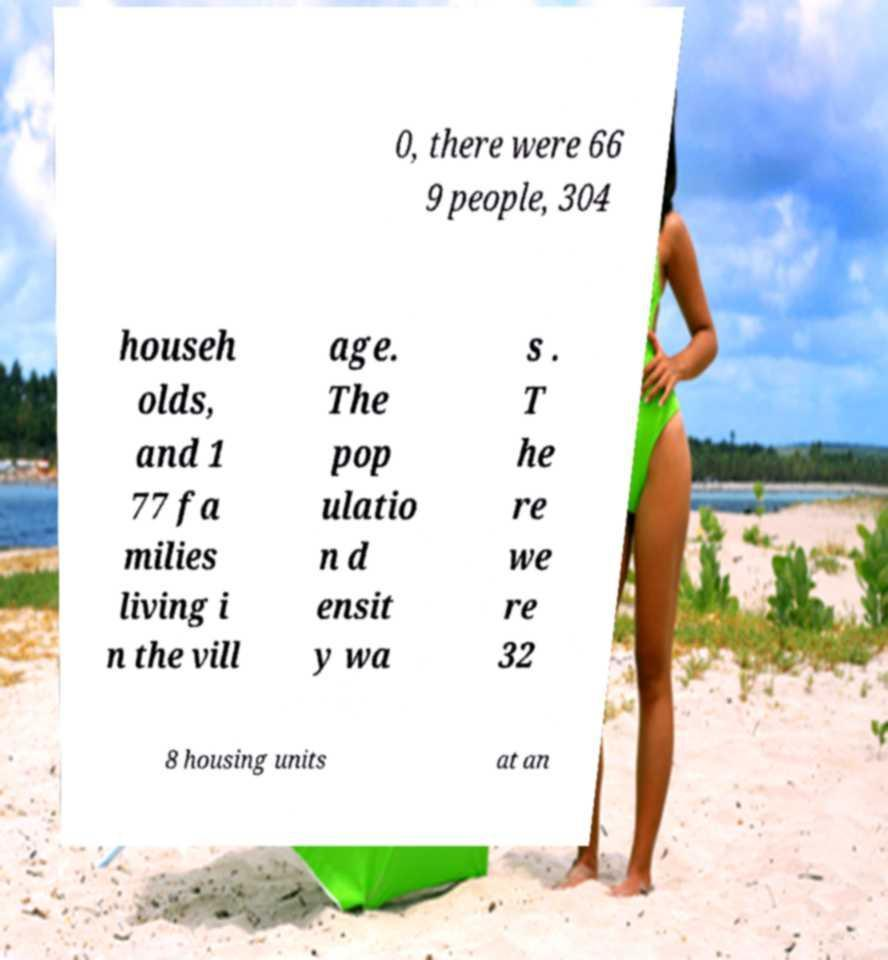What messages or text are displayed in this image? I need them in a readable, typed format. 0, there were 66 9 people, 304 househ olds, and 1 77 fa milies living i n the vill age. The pop ulatio n d ensit y wa s . T he re we re 32 8 housing units at an 